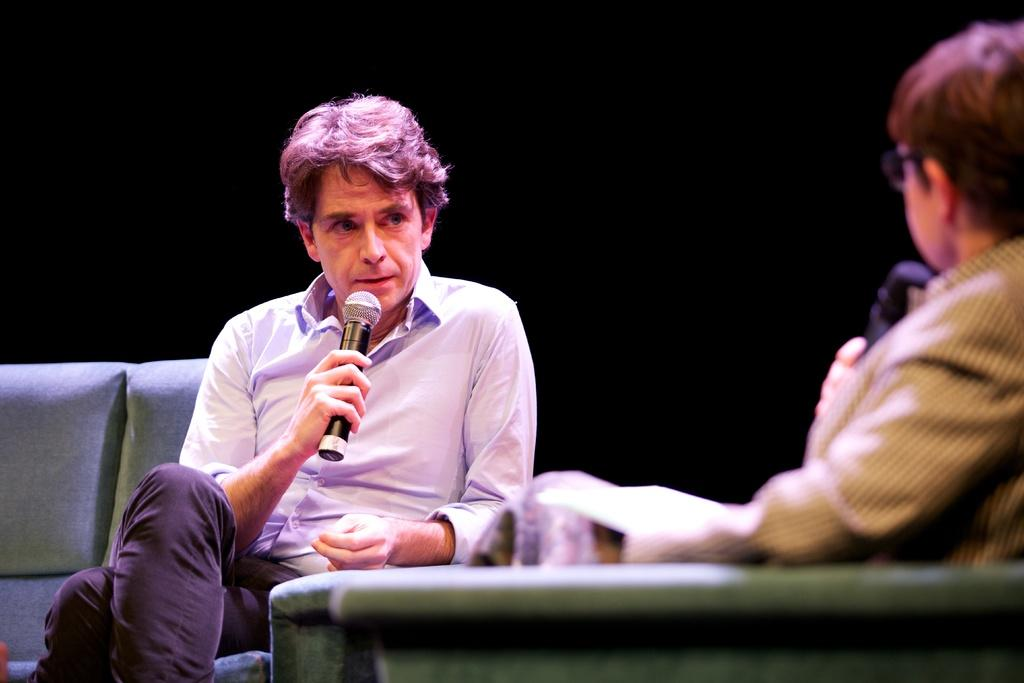How many people are in the image? There are two people in the image. What are the people doing in the image? The people are sitting in the image. What objects are the people holding in the image? The people are holding microphones in the image. What type of furniture is present in the image? There is a sofa and a chair in the image. What can be said about the lighting in the image? The background of the image is dark. What type of insurance policy are the people discussing in the image? There is no indication in the image that the people are discussing insurance policies. 